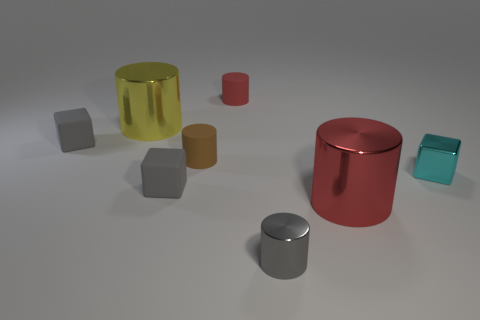Subtract all red metal cylinders. How many cylinders are left? 4 Add 1 cyan metal objects. How many objects exist? 9 Subtract all gray blocks. How many blocks are left? 1 Subtract 0 yellow blocks. How many objects are left? 8 Subtract all blocks. How many objects are left? 5 Subtract 1 blocks. How many blocks are left? 2 Subtract all gray cylinders. Subtract all yellow cubes. How many cylinders are left? 4 Subtract all cyan balls. How many purple cylinders are left? 0 Subtract all big purple blocks. Subtract all cyan metallic objects. How many objects are left? 7 Add 1 yellow shiny objects. How many yellow shiny objects are left? 2 